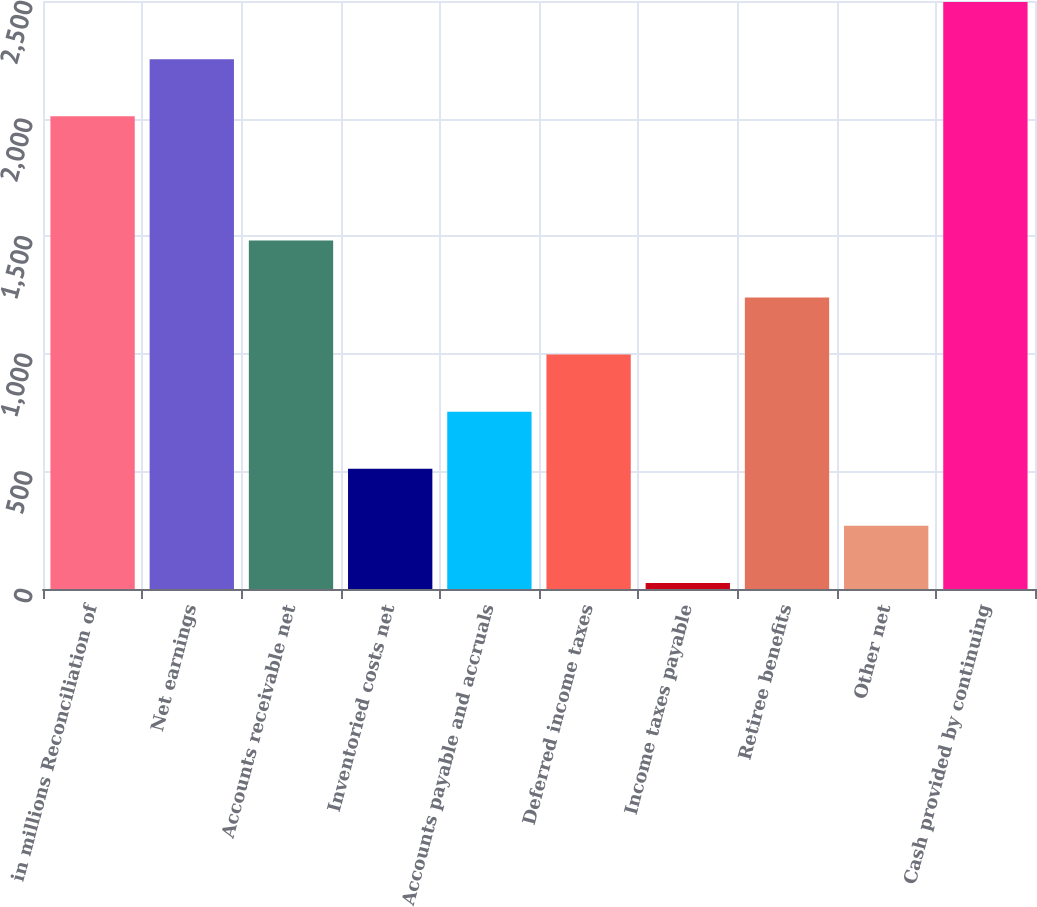Convert chart. <chart><loc_0><loc_0><loc_500><loc_500><bar_chart><fcel>in millions Reconciliation of<fcel>Net earnings<fcel>Accounts receivable net<fcel>Inventoried costs net<fcel>Accounts payable and accruals<fcel>Deferred income taxes<fcel>Income taxes payable<fcel>Retiree benefits<fcel>Other net<fcel>Cash provided by continuing<nl><fcel>2010<fcel>2252.7<fcel>1482.2<fcel>511.4<fcel>754.1<fcel>996.8<fcel>26<fcel>1239.5<fcel>268.7<fcel>2495.4<nl></chart> 